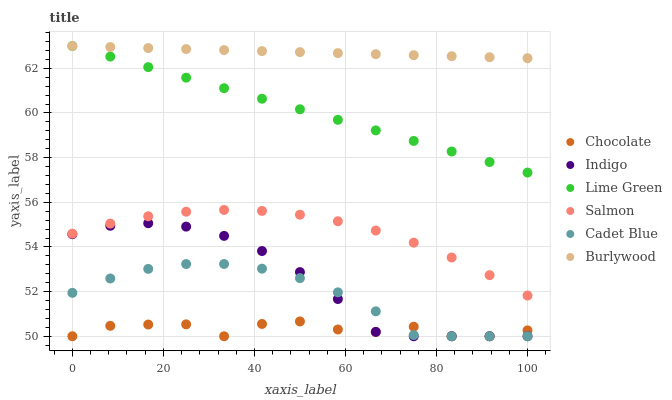Does Chocolate have the minimum area under the curve?
Answer yes or no. Yes. Does Burlywood have the maximum area under the curve?
Answer yes or no. Yes. Does Indigo have the minimum area under the curve?
Answer yes or no. No. Does Indigo have the maximum area under the curve?
Answer yes or no. No. Is Burlywood the smoothest?
Answer yes or no. Yes. Is Chocolate the roughest?
Answer yes or no. Yes. Is Indigo the smoothest?
Answer yes or no. No. Is Indigo the roughest?
Answer yes or no. No. Does Cadet Blue have the lowest value?
Answer yes or no. Yes. Does Burlywood have the lowest value?
Answer yes or no. No. Does Lime Green have the highest value?
Answer yes or no. Yes. Does Indigo have the highest value?
Answer yes or no. No. Is Chocolate less than Lime Green?
Answer yes or no. Yes. Is Burlywood greater than Indigo?
Answer yes or no. Yes. Does Chocolate intersect Cadet Blue?
Answer yes or no. Yes. Is Chocolate less than Cadet Blue?
Answer yes or no. No. Is Chocolate greater than Cadet Blue?
Answer yes or no. No. Does Chocolate intersect Lime Green?
Answer yes or no. No. 